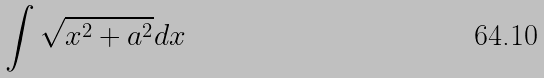<formula> <loc_0><loc_0><loc_500><loc_500>\int \sqrt { x ^ { 2 } + a ^ { 2 } } d x</formula> 